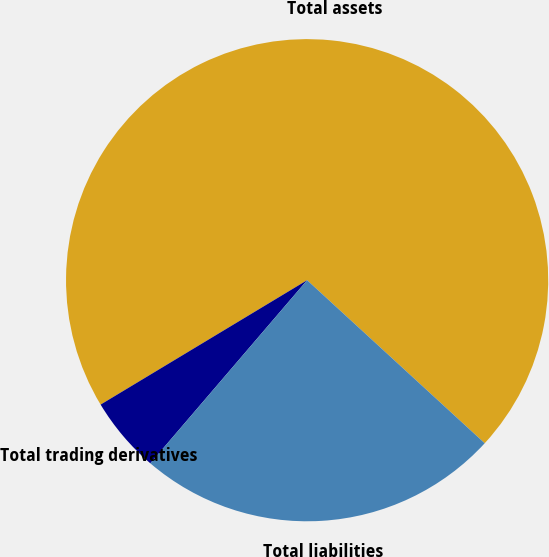Convert chart to OTSL. <chart><loc_0><loc_0><loc_500><loc_500><pie_chart><fcel>Total assets<fcel>Total trading derivatives<fcel>Total liabilities<nl><fcel>70.45%<fcel>5.1%<fcel>24.45%<nl></chart> 